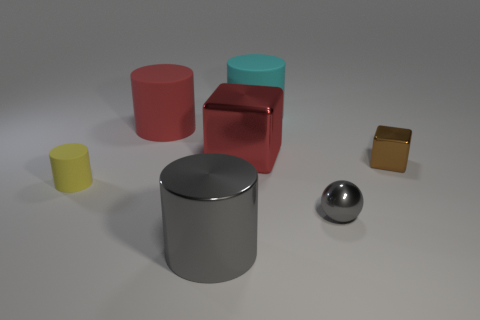Is the shape of the yellow thing the same as the red object that is right of the big gray shiny thing?
Your response must be concise. No. There is a cylinder that is the same color as the ball; what size is it?
Make the answer very short. Large. How many things are large metallic cylinders or red things?
Keep it short and to the point. 3. The gray object to the left of the large rubber thing that is on the right side of the red matte object is what shape?
Your answer should be very brief. Cylinder. Is the shape of the big metallic thing behind the big shiny cylinder the same as  the yellow object?
Your answer should be compact. No. What size is the red block that is made of the same material as the brown object?
Your answer should be compact. Large. What number of things are large matte cylinders that are right of the red metallic thing or objects that are in front of the brown metal thing?
Provide a succinct answer. 4. Are there an equal number of gray shiny balls to the left of the tiny gray metal object and big red cylinders in front of the yellow cylinder?
Your answer should be very brief. Yes. What color is the large matte cylinder that is left of the gray cylinder?
Your answer should be compact. Red. There is a large metallic cube; is its color the same as the small object that is left of the cyan matte cylinder?
Make the answer very short. No. 